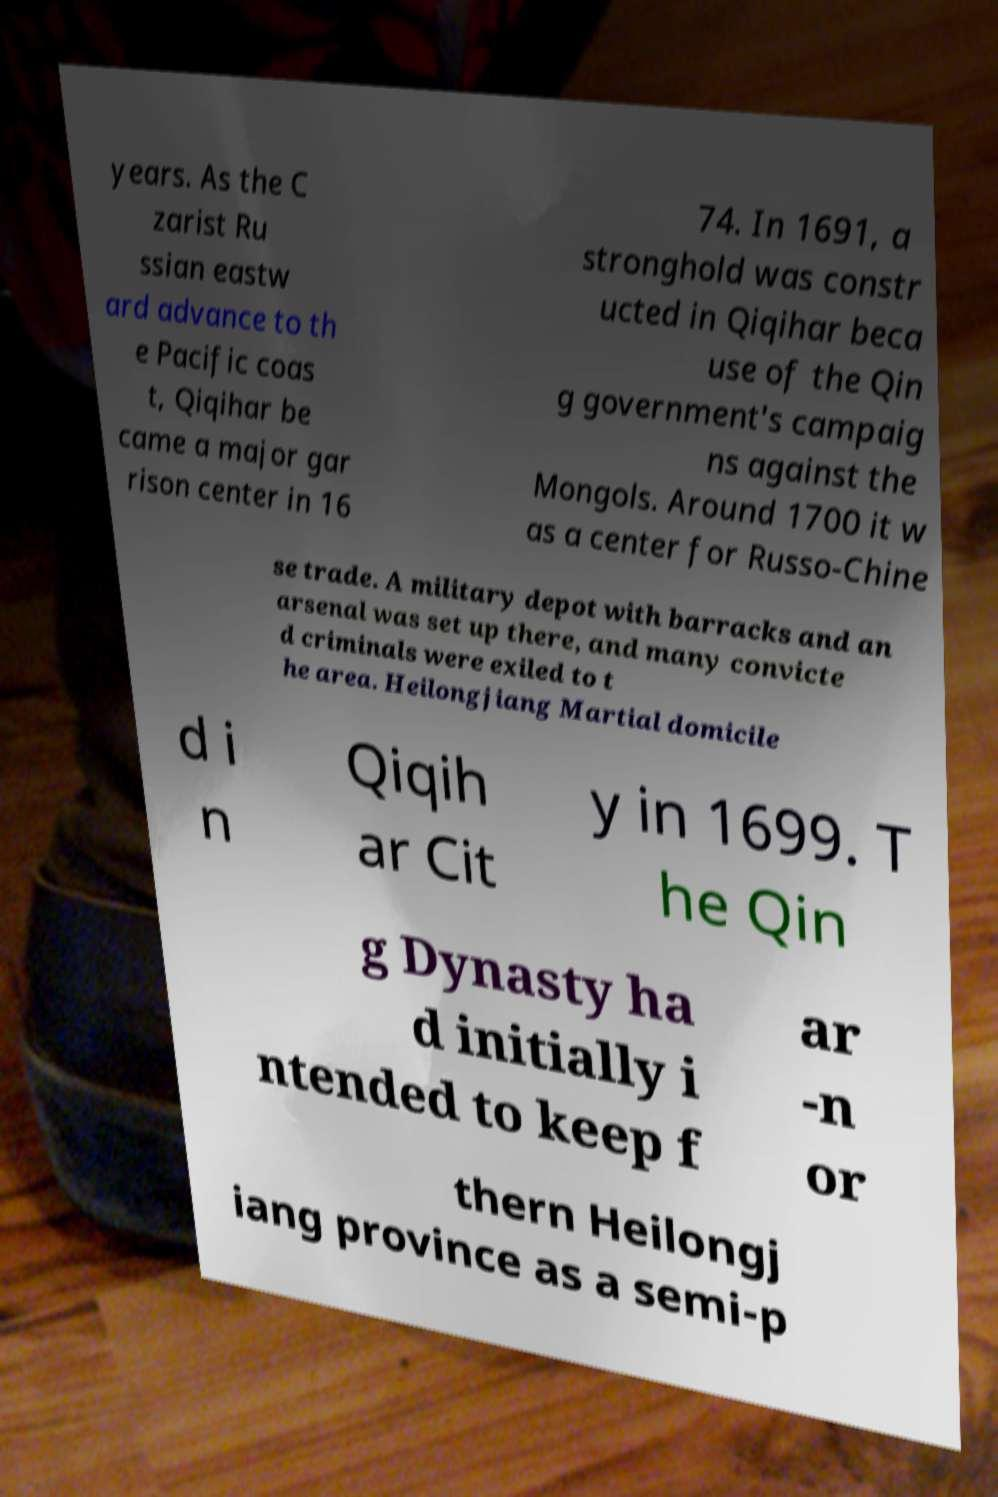What messages or text are displayed in this image? I need them in a readable, typed format. years. As the C zarist Ru ssian eastw ard advance to th e Pacific coas t, Qiqihar be came a major gar rison center in 16 74. In 1691, a stronghold was constr ucted in Qiqihar beca use of the Qin g government's campaig ns against the Mongols. Around 1700 it w as a center for Russo-Chine se trade. A military depot with barracks and an arsenal was set up there, and many convicte d criminals were exiled to t he area. Heilongjiang Martial domicile d i n Qiqih ar Cit y in 1699. T he Qin g Dynasty ha d initially i ntended to keep f ar -n or thern Heilongj iang province as a semi-p 